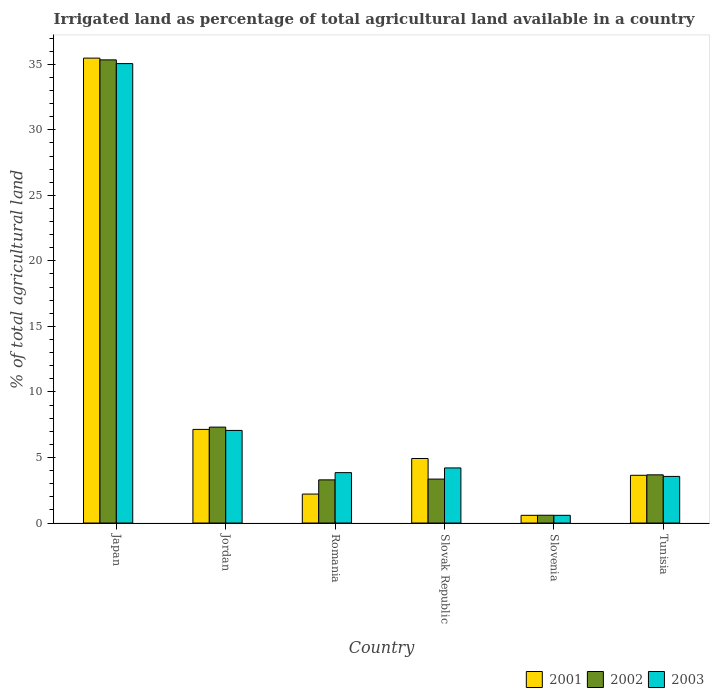How many groups of bars are there?
Offer a very short reply. 6. Are the number of bars per tick equal to the number of legend labels?
Ensure brevity in your answer.  Yes. How many bars are there on the 6th tick from the left?
Ensure brevity in your answer.  3. What is the label of the 2nd group of bars from the left?
Your answer should be compact. Jordan. In how many cases, is the number of bars for a given country not equal to the number of legend labels?
Your answer should be very brief. 0. What is the percentage of irrigated land in 2001 in Slovenia?
Offer a very short reply. 0.59. Across all countries, what is the maximum percentage of irrigated land in 2003?
Your answer should be very brief. 35.05. Across all countries, what is the minimum percentage of irrigated land in 2001?
Make the answer very short. 0.59. In which country was the percentage of irrigated land in 2002 minimum?
Offer a terse response. Slovenia. What is the total percentage of irrigated land in 2003 in the graph?
Provide a short and direct response. 54.31. What is the difference between the percentage of irrigated land in 2001 in Slovak Republic and that in Tunisia?
Your answer should be very brief. 1.28. What is the difference between the percentage of irrigated land in 2003 in Tunisia and the percentage of irrigated land in 2001 in Slovak Republic?
Your answer should be compact. -1.37. What is the average percentage of irrigated land in 2002 per country?
Provide a short and direct response. 8.93. What is the difference between the percentage of irrigated land of/in 2003 and percentage of irrigated land of/in 2001 in Tunisia?
Offer a very short reply. -0.09. What is the ratio of the percentage of irrigated land in 2001 in Japan to that in Slovak Republic?
Provide a succinct answer. 7.21. What is the difference between the highest and the second highest percentage of irrigated land in 2003?
Provide a succinct answer. 30.85. What is the difference between the highest and the lowest percentage of irrigated land in 2003?
Offer a terse response. 34.46. In how many countries, is the percentage of irrigated land in 2002 greater than the average percentage of irrigated land in 2002 taken over all countries?
Make the answer very short. 1. Is the sum of the percentage of irrigated land in 2001 in Romania and Slovenia greater than the maximum percentage of irrigated land in 2002 across all countries?
Your answer should be compact. No. What does the 3rd bar from the right in Tunisia represents?
Ensure brevity in your answer.  2001. Does the graph contain grids?
Your answer should be compact. No. Where does the legend appear in the graph?
Offer a very short reply. Bottom right. How many legend labels are there?
Make the answer very short. 3. How are the legend labels stacked?
Give a very brief answer. Horizontal. What is the title of the graph?
Offer a very short reply. Irrigated land as percentage of total agricultural land available in a country. What is the label or title of the X-axis?
Provide a short and direct response. Country. What is the label or title of the Y-axis?
Offer a very short reply. % of total agricultural land. What is the % of total agricultural land of 2001 in Japan?
Provide a short and direct response. 35.47. What is the % of total agricultural land of 2002 in Japan?
Make the answer very short. 35.33. What is the % of total agricultural land of 2003 in Japan?
Keep it short and to the point. 35.05. What is the % of total agricultural land of 2001 in Jordan?
Your answer should be very brief. 7.14. What is the % of total agricultural land of 2002 in Jordan?
Offer a terse response. 7.32. What is the % of total agricultural land of 2003 in Jordan?
Your answer should be very brief. 7.06. What is the % of total agricultural land in 2001 in Romania?
Give a very brief answer. 2.21. What is the % of total agricultural land of 2002 in Romania?
Keep it short and to the point. 3.29. What is the % of total agricultural land of 2003 in Romania?
Offer a very short reply. 3.84. What is the % of total agricultural land in 2001 in Slovak Republic?
Offer a terse response. 4.92. What is the % of total agricultural land in 2002 in Slovak Republic?
Your answer should be very brief. 3.35. What is the % of total agricultural land in 2003 in Slovak Republic?
Make the answer very short. 4.2. What is the % of total agricultural land of 2001 in Slovenia?
Ensure brevity in your answer.  0.59. What is the % of total agricultural land in 2002 in Slovenia?
Provide a succinct answer. 0.59. What is the % of total agricultural land in 2003 in Slovenia?
Ensure brevity in your answer.  0.59. What is the % of total agricultural land in 2001 in Tunisia?
Provide a succinct answer. 3.64. What is the % of total agricultural land of 2002 in Tunisia?
Your answer should be compact. 3.68. What is the % of total agricultural land of 2003 in Tunisia?
Your response must be concise. 3.56. Across all countries, what is the maximum % of total agricultural land in 2001?
Offer a terse response. 35.47. Across all countries, what is the maximum % of total agricultural land in 2002?
Your response must be concise. 35.33. Across all countries, what is the maximum % of total agricultural land of 2003?
Give a very brief answer. 35.05. Across all countries, what is the minimum % of total agricultural land in 2001?
Ensure brevity in your answer.  0.59. Across all countries, what is the minimum % of total agricultural land of 2002?
Give a very brief answer. 0.59. Across all countries, what is the minimum % of total agricultural land in 2003?
Provide a succinct answer. 0.59. What is the total % of total agricultural land of 2001 in the graph?
Your answer should be compact. 53.97. What is the total % of total agricultural land of 2002 in the graph?
Make the answer very short. 53.57. What is the total % of total agricultural land in 2003 in the graph?
Keep it short and to the point. 54.31. What is the difference between the % of total agricultural land of 2001 in Japan and that in Jordan?
Keep it short and to the point. 28.33. What is the difference between the % of total agricultural land of 2002 in Japan and that in Jordan?
Provide a short and direct response. 28.02. What is the difference between the % of total agricultural land in 2003 in Japan and that in Jordan?
Provide a succinct answer. 27.99. What is the difference between the % of total agricultural land in 2001 in Japan and that in Romania?
Keep it short and to the point. 33.26. What is the difference between the % of total agricultural land of 2002 in Japan and that in Romania?
Your answer should be compact. 32.04. What is the difference between the % of total agricultural land in 2003 in Japan and that in Romania?
Offer a very short reply. 31.21. What is the difference between the % of total agricultural land in 2001 in Japan and that in Slovak Republic?
Keep it short and to the point. 30.55. What is the difference between the % of total agricultural land of 2002 in Japan and that in Slovak Republic?
Offer a very short reply. 31.98. What is the difference between the % of total agricultural land in 2003 in Japan and that in Slovak Republic?
Offer a terse response. 30.85. What is the difference between the % of total agricultural land in 2001 in Japan and that in Slovenia?
Offer a terse response. 34.88. What is the difference between the % of total agricultural land of 2002 in Japan and that in Slovenia?
Ensure brevity in your answer.  34.74. What is the difference between the % of total agricultural land of 2003 in Japan and that in Slovenia?
Make the answer very short. 34.46. What is the difference between the % of total agricultural land of 2001 in Japan and that in Tunisia?
Give a very brief answer. 31.83. What is the difference between the % of total agricultural land of 2002 in Japan and that in Tunisia?
Offer a terse response. 31.66. What is the difference between the % of total agricultural land in 2003 in Japan and that in Tunisia?
Offer a very short reply. 31.49. What is the difference between the % of total agricultural land of 2001 in Jordan and that in Romania?
Your response must be concise. 4.93. What is the difference between the % of total agricultural land in 2002 in Jordan and that in Romania?
Your answer should be very brief. 4.02. What is the difference between the % of total agricultural land of 2003 in Jordan and that in Romania?
Your answer should be compact. 3.22. What is the difference between the % of total agricultural land of 2001 in Jordan and that in Slovak Republic?
Your answer should be very brief. 2.22. What is the difference between the % of total agricultural land of 2002 in Jordan and that in Slovak Republic?
Your response must be concise. 3.96. What is the difference between the % of total agricultural land in 2003 in Jordan and that in Slovak Republic?
Your response must be concise. 2.86. What is the difference between the % of total agricultural land in 2001 in Jordan and that in Slovenia?
Your response must be concise. 6.55. What is the difference between the % of total agricultural land of 2002 in Jordan and that in Slovenia?
Give a very brief answer. 6.72. What is the difference between the % of total agricultural land of 2003 in Jordan and that in Slovenia?
Provide a succinct answer. 6.48. What is the difference between the % of total agricultural land of 2001 in Jordan and that in Tunisia?
Provide a short and direct response. 3.5. What is the difference between the % of total agricultural land in 2002 in Jordan and that in Tunisia?
Give a very brief answer. 3.64. What is the difference between the % of total agricultural land of 2003 in Jordan and that in Tunisia?
Make the answer very short. 3.51. What is the difference between the % of total agricultural land of 2001 in Romania and that in Slovak Republic?
Keep it short and to the point. -2.71. What is the difference between the % of total agricultural land of 2002 in Romania and that in Slovak Republic?
Your answer should be compact. -0.06. What is the difference between the % of total agricultural land of 2003 in Romania and that in Slovak Republic?
Provide a short and direct response. -0.36. What is the difference between the % of total agricultural land in 2001 in Romania and that in Slovenia?
Offer a very short reply. 1.62. What is the difference between the % of total agricultural land of 2002 in Romania and that in Slovenia?
Give a very brief answer. 2.7. What is the difference between the % of total agricultural land of 2003 in Romania and that in Slovenia?
Provide a short and direct response. 3.26. What is the difference between the % of total agricultural land in 2001 in Romania and that in Tunisia?
Make the answer very short. -1.43. What is the difference between the % of total agricultural land of 2002 in Romania and that in Tunisia?
Provide a succinct answer. -0.38. What is the difference between the % of total agricultural land of 2003 in Romania and that in Tunisia?
Give a very brief answer. 0.29. What is the difference between the % of total agricultural land in 2001 in Slovak Republic and that in Slovenia?
Ensure brevity in your answer.  4.33. What is the difference between the % of total agricultural land of 2002 in Slovak Republic and that in Slovenia?
Provide a succinct answer. 2.76. What is the difference between the % of total agricultural land in 2003 in Slovak Republic and that in Slovenia?
Offer a terse response. 3.62. What is the difference between the % of total agricultural land of 2001 in Slovak Republic and that in Tunisia?
Offer a very short reply. 1.28. What is the difference between the % of total agricultural land in 2002 in Slovak Republic and that in Tunisia?
Your answer should be compact. -0.32. What is the difference between the % of total agricultural land of 2003 in Slovak Republic and that in Tunisia?
Your response must be concise. 0.65. What is the difference between the % of total agricultural land in 2001 in Slovenia and that in Tunisia?
Provide a short and direct response. -3.05. What is the difference between the % of total agricultural land of 2002 in Slovenia and that in Tunisia?
Your response must be concise. -3.08. What is the difference between the % of total agricultural land in 2003 in Slovenia and that in Tunisia?
Your answer should be compact. -2.97. What is the difference between the % of total agricultural land in 2001 in Japan and the % of total agricultural land in 2002 in Jordan?
Provide a short and direct response. 28.15. What is the difference between the % of total agricultural land of 2001 in Japan and the % of total agricultural land of 2003 in Jordan?
Your answer should be compact. 28.4. What is the difference between the % of total agricultural land of 2002 in Japan and the % of total agricultural land of 2003 in Jordan?
Your response must be concise. 28.27. What is the difference between the % of total agricultural land in 2001 in Japan and the % of total agricultural land in 2002 in Romania?
Ensure brevity in your answer.  32.18. What is the difference between the % of total agricultural land in 2001 in Japan and the % of total agricultural land in 2003 in Romania?
Your response must be concise. 31.62. What is the difference between the % of total agricultural land in 2002 in Japan and the % of total agricultural land in 2003 in Romania?
Your answer should be compact. 31.49. What is the difference between the % of total agricultural land of 2001 in Japan and the % of total agricultural land of 2002 in Slovak Republic?
Your answer should be very brief. 32.12. What is the difference between the % of total agricultural land of 2001 in Japan and the % of total agricultural land of 2003 in Slovak Republic?
Offer a very short reply. 31.26. What is the difference between the % of total agricultural land in 2002 in Japan and the % of total agricultural land in 2003 in Slovak Republic?
Your response must be concise. 31.13. What is the difference between the % of total agricultural land in 2001 in Japan and the % of total agricultural land in 2002 in Slovenia?
Provide a short and direct response. 34.87. What is the difference between the % of total agricultural land in 2001 in Japan and the % of total agricultural land in 2003 in Slovenia?
Offer a terse response. 34.88. What is the difference between the % of total agricultural land of 2002 in Japan and the % of total agricultural land of 2003 in Slovenia?
Your answer should be compact. 34.75. What is the difference between the % of total agricultural land of 2001 in Japan and the % of total agricultural land of 2002 in Tunisia?
Make the answer very short. 31.79. What is the difference between the % of total agricultural land of 2001 in Japan and the % of total agricultural land of 2003 in Tunisia?
Your answer should be very brief. 31.91. What is the difference between the % of total agricultural land of 2002 in Japan and the % of total agricultural land of 2003 in Tunisia?
Offer a terse response. 31.78. What is the difference between the % of total agricultural land in 2001 in Jordan and the % of total agricultural land in 2002 in Romania?
Your response must be concise. 3.85. What is the difference between the % of total agricultural land in 2001 in Jordan and the % of total agricultural land in 2003 in Romania?
Provide a short and direct response. 3.3. What is the difference between the % of total agricultural land in 2002 in Jordan and the % of total agricultural land in 2003 in Romania?
Provide a succinct answer. 3.47. What is the difference between the % of total agricultural land of 2001 in Jordan and the % of total agricultural land of 2002 in Slovak Republic?
Your response must be concise. 3.79. What is the difference between the % of total agricultural land in 2001 in Jordan and the % of total agricultural land in 2003 in Slovak Republic?
Give a very brief answer. 2.94. What is the difference between the % of total agricultural land in 2002 in Jordan and the % of total agricultural land in 2003 in Slovak Republic?
Your response must be concise. 3.11. What is the difference between the % of total agricultural land of 2001 in Jordan and the % of total agricultural land of 2002 in Slovenia?
Give a very brief answer. 6.55. What is the difference between the % of total agricultural land in 2001 in Jordan and the % of total agricultural land in 2003 in Slovenia?
Provide a succinct answer. 6.55. What is the difference between the % of total agricultural land in 2002 in Jordan and the % of total agricultural land in 2003 in Slovenia?
Offer a terse response. 6.73. What is the difference between the % of total agricultural land of 2001 in Jordan and the % of total agricultural land of 2002 in Tunisia?
Give a very brief answer. 3.47. What is the difference between the % of total agricultural land of 2001 in Jordan and the % of total agricultural land of 2003 in Tunisia?
Offer a very short reply. 3.59. What is the difference between the % of total agricultural land in 2002 in Jordan and the % of total agricultural land in 2003 in Tunisia?
Provide a short and direct response. 3.76. What is the difference between the % of total agricultural land in 2001 in Romania and the % of total agricultural land in 2002 in Slovak Republic?
Provide a short and direct response. -1.14. What is the difference between the % of total agricultural land in 2001 in Romania and the % of total agricultural land in 2003 in Slovak Republic?
Provide a short and direct response. -1.99. What is the difference between the % of total agricultural land in 2002 in Romania and the % of total agricultural land in 2003 in Slovak Republic?
Give a very brief answer. -0.91. What is the difference between the % of total agricultural land in 2001 in Romania and the % of total agricultural land in 2002 in Slovenia?
Your answer should be compact. 1.62. What is the difference between the % of total agricultural land of 2001 in Romania and the % of total agricultural land of 2003 in Slovenia?
Offer a very short reply. 1.62. What is the difference between the % of total agricultural land in 2002 in Romania and the % of total agricultural land in 2003 in Slovenia?
Give a very brief answer. 2.71. What is the difference between the % of total agricultural land in 2001 in Romania and the % of total agricultural land in 2002 in Tunisia?
Your answer should be very brief. -1.47. What is the difference between the % of total agricultural land of 2001 in Romania and the % of total agricultural land of 2003 in Tunisia?
Ensure brevity in your answer.  -1.35. What is the difference between the % of total agricultural land in 2002 in Romania and the % of total agricultural land in 2003 in Tunisia?
Your answer should be compact. -0.26. What is the difference between the % of total agricultural land in 2001 in Slovak Republic and the % of total agricultural land in 2002 in Slovenia?
Make the answer very short. 4.33. What is the difference between the % of total agricultural land in 2001 in Slovak Republic and the % of total agricultural land in 2003 in Slovenia?
Provide a succinct answer. 4.33. What is the difference between the % of total agricultural land of 2002 in Slovak Republic and the % of total agricultural land of 2003 in Slovenia?
Your answer should be compact. 2.76. What is the difference between the % of total agricultural land in 2001 in Slovak Republic and the % of total agricultural land in 2002 in Tunisia?
Ensure brevity in your answer.  1.25. What is the difference between the % of total agricultural land in 2001 in Slovak Republic and the % of total agricultural land in 2003 in Tunisia?
Offer a terse response. 1.37. What is the difference between the % of total agricultural land in 2002 in Slovak Republic and the % of total agricultural land in 2003 in Tunisia?
Give a very brief answer. -0.2. What is the difference between the % of total agricultural land of 2001 in Slovenia and the % of total agricultural land of 2002 in Tunisia?
Give a very brief answer. -3.09. What is the difference between the % of total agricultural land in 2001 in Slovenia and the % of total agricultural land in 2003 in Tunisia?
Ensure brevity in your answer.  -2.97. What is the difference between the % of total agricultural land of 2002 in Slovenia and the % of total agricultural land of 2003 in Tunisia?
Your response must be concise. -2.96. What is the average % of total agricultural land of 2001 per country?
Your answer should be very brief. 9. What is the average % of total agricultural land of 2002 per country?
Ensure brevity in your answer.  8.93. What is the average % of total agricultural land in 2003 per country?
Ensure brevity in your answer.  9.05. What is the difference between the % of total agricultural land of 2001 and % of total agricultural land of 2002 in Japan?
Offer a terse response. 0.13. What is the difference between the % of total agricultural land of 2001 and % of total agricultural land of 2003 in Japan?
Give a very brief answer. 0.42. What is the difference between the % of total agricultural land in 2002 and % of total agricultural land in 2003 in Japan?
Ensure brevity in your answer.  0.28. What is the difference between the % of total agricultural land of 2001 and % of total agricultural land of 2002 in Jordan?
Give a very brief answer. -0.17. What is the difference between the % of total agricultural land in 2001 and % of total agricultural land in 2003 in Jordan?
Offer a very short reply. 0.08. What is the difference between the % of total agricultural land of 2002 and % of total agricultural land of 2003 in Jordan?
Ensure brevity in your answer.  0.25. What is the difference between the % of total agricultural land of 2001 and % of total agricultural land of 2002 in Romania?
Offer a very short reply. -1.08. What is the difference between the % of total agricultural land in 2001 and % of total agricultural land in 2003 in Romania?
Your answer should be compact. -1.63. What is the difference between the % of total agricultural land in 2002 and % of total agricultural land in 2003 in Romania?
Offer a terse response. -0.55. What is the difference between the % of total agricultural land of 2001 and % of total agricultural land of 2002 in Slovak Republic?
Provide a succinct answer. 1.57. What is the difference between the % of total agricultural land in 2001 and % of total agricultural land in 2003 in Slovak Republic?
Keep it short and to the point. 0.72. What is the difference between the % of total agricultural land in 2002 and % of total agricultural land in 2003 in Slovak Republic?
Give a very brief answer. -0.85. What is the difference between the % of total agricultural land of 2001 and % of total agricultural land of 2002 in Slovenia?
Your response must be concise. -0.01. What is the difference between the % of total agricultural land in 2001 and % of total agricultural land in 2003 in Slovenia?
Provide a succinct answer. 0. What is the difference between the % of total agricultural land in 2002 and % of total agricultural land in 2003 in Slovenia?
Offer a terse response. 0.01. What is the difference between the % of total agricultural land of 2001 and % of total agricultural land of 2002 in Tunisia?
Provide a succinct answer. -0.03. What is the difference between the % of total agricultural land in 2001 and % of total agricultural land in 2003 in Tunisia?
Make the answer very short. 0.09. What is the difference between the % of total agricultural land of 2002 and % of total agricultural land of 2003 in Tunisia?
Keep it short and to the point. 0.12. What is the ratio of the % of total agricultural land in 2001 in Japan to that in Jordan?
Ensure brevity in your answer.  4.97. What is the ratio of the % of total agricultural land of 2002 in Japan to that in Jordan?
Provide a short and direct response. 4.83. What is the ratio of the % of total agricultural land of 2003 in Japan to that in Jordan?
Provide a succinct answer. 4.96. What is the ratio of the % of total agricultural land in 2001 in Japan to that in Romania?
Provide a short and direct response. 16.05. What is the ratio of the % of total agricultural land in 2002 in Japan to that in Romania?
Keep it short and to the point. 10.73. What is the ratio of the % of total agricultural land of 2003 in Japan to that in Romania?
Provide a succinct answer. 9.12. What is the ratio of the % of total agricultural land in 2001 in Japan to that in Slovak Republic?
Provide a succinct answer. 7.21. What is the ratio of the % of total agricultural land in 2002 in Japan to that in Slovak Republic?
Your response must be concise. 10.54. What is the ratio of the % of total agricultural land of 2003 in Japan to that in Slovak Republic?
Offer a terse response. 8.34. What is the ratio of the % of total agricultural land of 2001 in Japan to that in Slovenia?
Provide a succinct answer. 60.3. What is the ratio of the % of total agricultural land of 2002 in Japan to that in Slovenia?
Provide a succinct answer. 59.48. What is the ratio of the % of total agricultural land of 2003 in Japan to that in Slovenia?
Your answer should be very brief. 59.59. What is the ratio of the % of total agricultural land in 2001 in Japan to that in Tunisia?
Make the answer very short. 9.74. What is the ratio of the % of total agricultural land in 2002 in Japan to that in Tunisia?
Provide a succinct answer. 9.61. What is the ratio of the % of total agricultural land in 2003 in Japan to that in Tunisia?
Your answer should be very brief. 9.85. What is the ratio of the % of total agricultural land in 2001 in Jordan to that in Romania?
Provide a succinct answer. 3.23. What is the ratio of the % of total agricultural land in 2002 in Jordan to that in Romania?
Offer a very short reply. 2.22. What is the ratio of the % of total agricultural land of 2003 in Jordan to that in Romania?
Ensure brevity in your answer.  1.84. What is the ratio of the % of total agricultural land of 2001 in Jordan to that in Slovak Republic?
Offer a terse response. 1.45. What is the ratio of the % of total agricultural land in 2002 in Jordan to that in Slovak Republic?
Ensure brevity in your answer.  2.18. What is the ratio of the % of total agricultural land in 2003 in Jordan to that in Slovak Republic?
Offer a terse response. 1.68. What is the ratio of the % of total agricultural land of 2001 in Jordan to that in Slovenia?
Provide a succinct answer. 12.14. What is the ratio of the % of total agricultural land in 2002 in Jordan to that in Slovenia?
Your answer should be very brief. 12.32. What is the ratio of the % of total agricultural land in 2003 in Jordan to that in Slovenia?
Keep it short and to the point. 12.01. What is the ratio of the % of total agricultural land in 2001 in Jordan to that in Tunisia?
Provide a succinct answer. 1.96. What is the ratio of the % of total agricultural land of 2002 in Jordan to that in Tunisia?
Your response must be concise. 1.99. What is the ratio of the % of total agricultural land in 2003 in Jordan to that in Tunisia?
Provide a short and direct response. 1.99. What is the ratio of the % of total agricultural land in 2001 in Romania to that in Slovak Republic?
Offer a very short reply. 0.45. What is the ratio of the % of total agricultural land in 2002 in Romania to that in Slovak Republic?
Ensure brevity in your answer.  0.98. What is the ratio of the % of total agricultural land of 2003 in Romania to that in Slovak Republic?
Provide a succinct answer. 0.91. What is the ratio of the % of total agricultural land of 2001 in Romania to that in Slovenia?
Offer a terse response. 3.76. What is the ratio of the % of total agricultural land of 2002 in Romania to that in Slovenia?
Your answer should be compact. 5.54. What is the ratio of the % of total agricultural land of 2003 in Romania to that in Slovenia?
Your answer should be compact. 6.54. What is the ratio of the % of total agricultural land in 2001 in Romania to that in Tunisia?
Offer a terse response. 0.61. What is the ratio of the % of total agricultural land in 2002 in Romania to that in Tunisia?
Provide a succinct answer. 0.9. What is the ratio of the % of total agricultural land in 2003 in Romania to that in Tunisia?
Keep it short and to the point. 1.08. What is the ratio of the % of total agricultural land of 2001 in Slovak Republic to that in Slovenia?
Keep it short and to the point. 8.37. What is the ratio of the % of total agricultural land in 2002 in Slovak Republic to that in Slovenia?
Provide a short and direct response. 5.64. What is the ratio of the % of total agricultural land in 2003 in Slovak Republic to that in Slovenia?
Provide a short and direct response. 7.15. What is the ratio of the % of total agricultural land in 2001 in Slovak Republic to that in Tunisia?
Give a very brief answer. 1.35. What is the ratio of the % of total agricultural land in 2002 in Slovak Republic to that in Tunisia?
Give a very brief answer. 0.91. What is the ratio of the % of total agricultural land of 2003 in Slovak Republic to that in Tunisia?
Provide a succinct answer. 1.18. What is the ratio of the % of total agricultural land in 2001 in Slovenia to that in Tunisia?
Provide a succinct answer. 0.16. What is the ratio of the % of total agricultural land in 2002 in Slovenia to that in Tunisia?
Keep it short and to the point. 0.16. What is the ratio of the % of total agricultural land of 2003 in Slovenia to that in Tunisia?
Make the answer very short. 0.17. What is the difference between the highest and the second highest % of total agricultural land in 2001?
Your answer should be compact. 28.33. What is the difference between the highest and the second highest % of total agricultural land of 2002?
Provide a short and direct response. 28.02. What is the difference between the highest and the second highest % of total agricultural land in 2003?
Your response must be concise. 27.99. What is the difference between the highest and the lowest % of total agricultural land in 2001?
Provide a succinct answer. 34.88. What is the difference between the highest and the lowest % of total agricultural land of 2002?
Provide a short and direct response. 34.74. What is the difference between the highest and the lowest % of total agricultural land in 2003?
Make the answer very short. 34.46. 